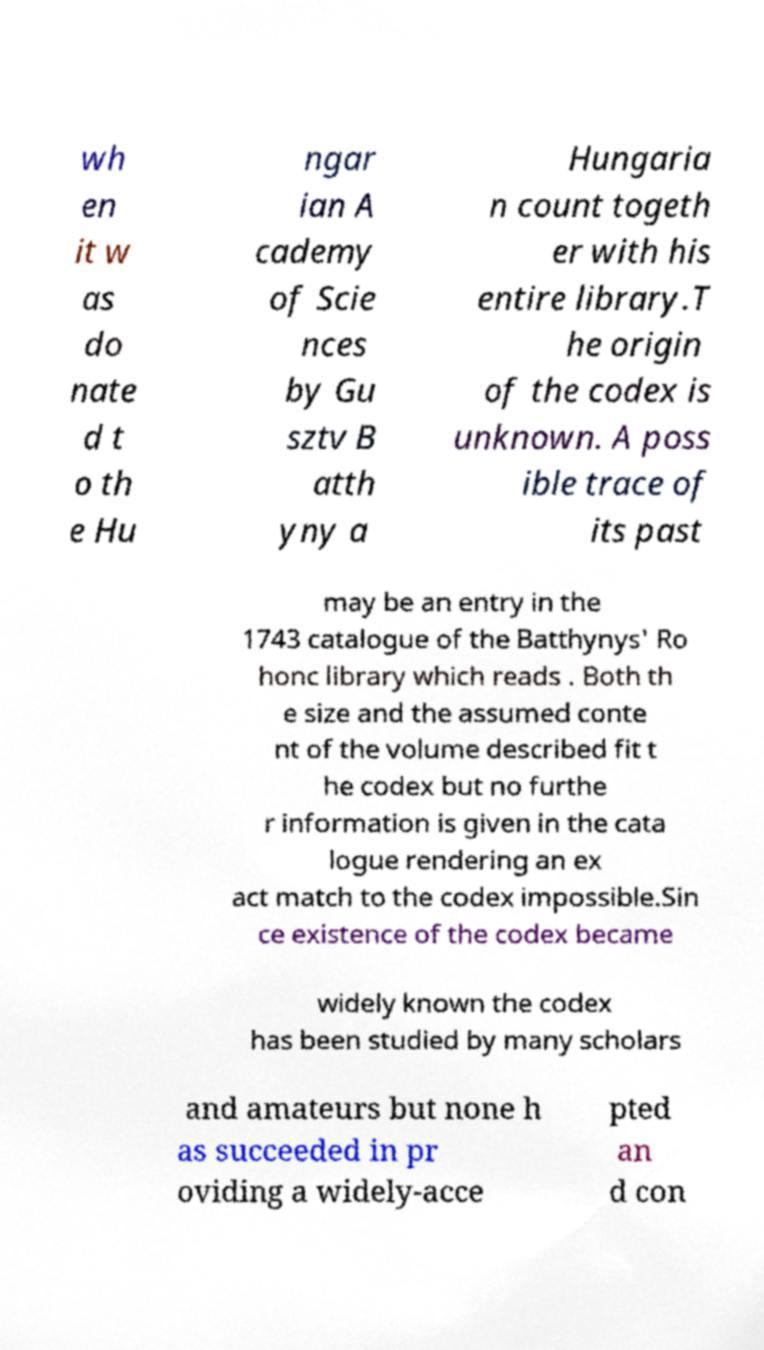I need the written content from this picture converted into text. Can you do that? wh en it w as do nate d t o th e Hu ngar ian A cademy of Scie nces by Gu sztv B atth yny a Hungaria n count togeth er with his entire library.T he origin of the codex is unknown. A poss ible trace of its past may be an entry in the 1743 catalogue of the Batthynys' Ro honc library which reads . Both th e size and the assumed conte nt of the volume described fit t he codex but no furthe r information is given in the cata logue rendering an ex act match to the codex impossible.Sin ce existence of the codex became widely known the codex has been studied by many scholars and amateurs but none h as succeeded in pr oviding a widely-acce pted an d con 